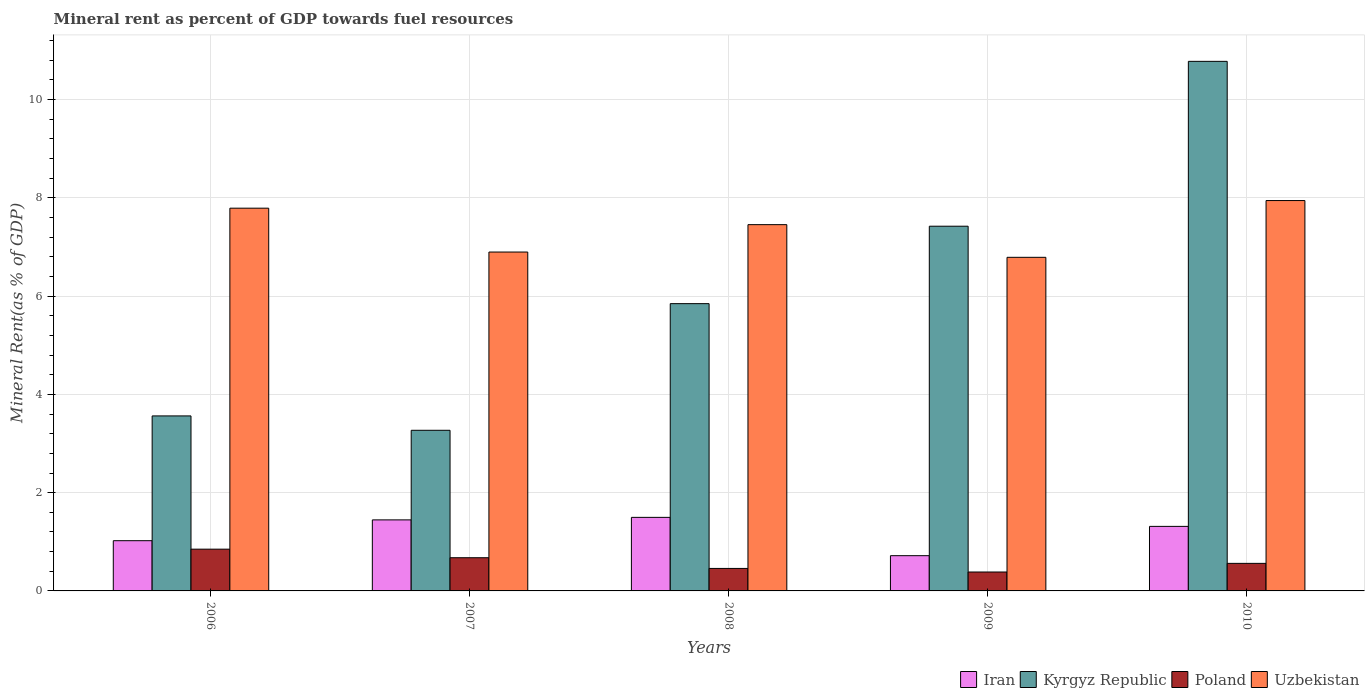How many different coloured bars are there?
Give a very brief answer. 4. How many groups of bars are there?
Offer a very short reply. 5. What is the mineral rent in Iran in 2010?
Your response must be concise. 1.31. Across all years, what is the maximum mineral rent in Uzbekistan?
Your answer should be compact. 7.95. Across all years, what is the minimum mineral rent in Poland?
Your answer should be very brief. 0.39. In which year was the mineral rent in Iran maximum?
Keep it short and to the point. 2008. What is the total mineral rent in Iran in the graph?
Your answer should be compact. 6. What is the difference between the mineral rent in Kyrgyz Republic in 2007 and that in 2008?
Offer a very short reply. -2.58. What is the difference between the mineral rent in Iran in 2007 and the mineral rent in Poland in 2008?
Your answer should be compact. 0.99. What is the average mineral rent in Uzbekistan per year?
Provide a short and direct response. 7.38. In the year 2007, what is the difference between the mineral rent in Kyrgyz Republic and mineral rent in Uzbekistan?
Provide a short and direct response. -3.63. What is the ratio of the mineral rent in Iran in 2006 to that in 2007?
Offer a very short reply. 0.71. Is the difference between the mineral rent in Kyrgyz Republic in 2008 and 2010 greater than the difference between the mineral rent in Uzbekistan in 2008 and 2010?
Provide a succinct answer. No. What is the difference between the highest and the second highest mineral rent in Uzbekistan?
Keep it short and to the point. 0.16. What is the difference between the highest and the lowest mineral rent in Uzbekistan?
Give a very brief answer. 1.16. In how many years, is the mineral rent in Kyrgyz Republic greater than the average mineral rent in Kyrgyz Republic taken over all years?
Your response must be concise. 2. Is it the case that in every year, the sum of the mineral rent in Poland and mineral rent in Iran is greater than the sum of mineral rent in Uzbekistan and mineral rent in Kyrgyz Republic?
Your answer should be very brief. No. What does the 1st bar from the left in 2008 represents?
Provide a short and direct response. Iran. What does the 1st bar from the right in 2007 represents?
Provide a succinct answer. Uzbekistan. Are all the bars in the graph horizontal?
Offer a very short reply. No. How many years are there in the graph?
Keep it short and to the point. 5. Are the values on the major ticks of Y-axis written in scientific E-notation?
Ensure brevity in your answer.  No. Does the graph contain any zero values?
Make the answer very short. No. Where does the legend appear in the graph?
Your answer should be very brief. Bottom right. How many legend labels are there?
Provide a succinct answer. 4. How are the legend labels stacked?
Your answer should be compact. Horizontal. What is the title of the graph?
Offer a very short reply. Mineral rent as percent of GDP towards fuel resources. Does "High income: nonOECD" appear as one of the legend labels in the graph?
Keep it short and to the point. No. What is the label or title of the X-axis?
Your answer should be very brief. Years. What is the label or title of the Y-axis?
Keep it short and to the point. Mineral Rent(as % of GDP). What is the Mineral Rent(as % of GDP) of Iran in 2006?
Make the answer very short. 1.02. What is the Mineral Rent(as % of GDP) of Kyrgyz Republic in 2006?
Provide a succinct answer. 3.56. What is the Mineral Rent(as % of GDP) in Poland in 2006?
Offer a terse response. 0.85. What is the Mineral Rent(as % of GDP) of Uzbekistan in 2006?
Keep it short and to the point. 7.79. What is the Mineral Rent(as % of GDP) in Iran in 2007?
Your answer should be compact. 1.45. What is the Mineral Rent(as % of GDP) in Kyrgyz Republic in 2007?
Provide a succinct answer. 3.27. What is the Mineral Rent(as % of GDP) in Poland in 2007?
Make the answer very short. 0.68. What is the Mineral Rent(as % of GDP) of Uzbekistan in 2007?
Provide a short and direct response. 6.9. What is the Mineral Rent(as % of GDP) of Iran in 2008?
Keep it short and to the point. 1.5. What is the Mineral Rent(as % of GDP) of Kyrgyz Republic in 2008?
Give a very brief answer. 5.85. What is the Mineral Rent(as % of GDP) in Poland in 2008?
Your response must be concise. 0.46. What is the Mineral Rent(as % of GDP) in Uzbekistan in 2008?
Your response must be concise. 7.45. What is the Mineral Rent(as % of GDP) of Iran in 2009?
Your answer should be very brief. 0.72. What is the Mineral Rent(as % of GDP) in Kyrgyz Republic in 2009?
Offer a terse response. 7.42. What is the Mineral Rent(as % of GDP) in Poland in 2009?
Provide a short and direct response. 0.39. What is the Mineral Rent(as % of GDP) of Uzbekistan in 2009?
Your answer should be compact. 6.79. What is the Mineral Rent(as % of GDP) of Iran in 2010?
Make the answer very short. 1.31. What is the Mineral Rent(as % of GDP) in Kyrgyz Republic in 2010?
Your response must be concise. 10.78. What is the Mineral Rent(as % of GDP) in Poland in 2010?
Your answer should be compact. 0.56. What is the Mineral Rent(as % of GDP) in Uzbekistan in 2010?
Keep it short and to the point. 7.95. Across all years, what is the maximum Mineral Rent(as % of GDP) in Iran?
Your response must be concise. 1.5. Across all years, what is the maximum Mineral Rent(as % of GDP) in Kyrgyz Republic?
Provide a succinct answer. 10.78. Across all years, what is the maximum Mineral Rent(as % of GDP) in Poland?
Offer a very short reply. 0.85. Across all years, what is the maximum Mineral Rent(as % of GDP) in Uzbekistan?
Make the answer very short. 7.95. Across all years, what is the minimum Mineral Rent(as % of GDP) in Iran?
Provide a short and direct response. 0.72. Across all years, what is the minimum Mineral Rent(as % of GDP) in Kyrgyz Republic?
Keep it short and to the point. 3.27. Across all years, what is the minimum Mineral Rent(as % of GDP) of Poland?
Your response must be concise. 0.39. Across all years, what is the minimum Mineral Rent(as % of GDP) of Uzbekistan?
Your answer should be very brief. 6.79. What is the total Mineral Rent(as % of GDP) in Iran in the graph?
Your answer should be very brief. 6. What is the total Mineral Rent(as % of GDP) of Kyrgyz Republic in the graph?
Give a very brief answer. 30.88. What is the total Mineral Rent(as % of GDP) of Poland in the graph?
Offer a very short reply. 2.93. What is the total Mineral Rent(as % of GDP) in Uzbekistan in the graph?
Provide a succinct answer. 36.88. What is the difference between the Mineral Rent(as % of GDP) in Iran in 2006 and that in 2007?
Provide a succinct answer. -0.42. What is the difference between the Mineral Rent(as % of GDP) of Kyrgyz Republic in 2006 and that in 2007?
Your answer should be compact. 0.29. What is the difference between the Mineral Rent(as % of GDP) of Poland in 2006 and that in 2007?
Your answer should be compact. 0.17. What is the difference between the Mineral Rent(as % of GDP) in Uzbekistan in 2006 and that in 2007?
Offer a very short reply. 0.89. What is the difference between the Mineral Rent(as % of GDP) in Iran in 2006 and that in 2008?
Ensure brevity in your answer.  -0.47. What is the difference between the Mineral Rent(as % of GDP) in Kyrgyz Republic in 2006 and that in 2008?
Keep it short and to the point. -2.29. What is the difference between the Mineral Rent(as % of GDP) of Poland in 2006 and that in 2008?
Your answer should be compact. 0.39. What is the difference between the Mineral Rent(as % of GDP) in Uzbekistan in 2006 and that in 2008?
Ensure brevity in your answer.  0.34. What is the difference between the Mineral Rent(as % of GDP) in Iran in 2006 and that in 2009?
Your answer should be very brief. 0.31. What is the difference between the Mineral Rent(as % of GDP) of Kyrgyz Republic in 2006 and that in 2009?
Offer a very short reply. -3.86. What is the difference between the Mineral Rent(as % of GDP) in Poland in 2006 and that in 2009?
Offer a terse response. 0.46. What is the difference between the Mineral Rent(as % of GDP) of Iran in 2006 and that in 2010?
Offer a terse response. -0.29. What is the difference between the Mineral Rent(as % of GDP) in Kyrgyz Republic in 2006 and that in 2010?
Ensure brevity in your answer.  -7.22. What is the difference between the Mineral Rent(as % of GDP) of Poland in 2006 and that in 2010?
Your answer should be compact. 0.29. What is the difference between the Mineral Rent(as % of GDP) in Uzbekistan in 2006 and that in 2010?
Ensure brevity in your answer.  -0.16. What is the difference between the Mineral Rent(as % of GDP) of Iran in 2007 and that in 2008?
Provide a succinct answer. -0.05. What is the difference between the Mineral Rent(as % of GDP) in Kyrgyz Republic in 2007 and that in 2008?
Your answer should be very brief. -2.58. What is the difference between the Mineral Rent(as % of GDP) of Poland in 2007 and that in 2008?
Your answer should be compact. 0.22. What is the difference between the Mineral Rent(as % of GDP) of Uzbekistan in 2007 and that in 2008?
Provide a short and direct response. -0.56. What is the difference between the Mineral Rent(as % of GDP) of Iran in 2007 and that in 2009?
Ensure brevity in your answer.  0.73. What is the difference between the Mineral Rent(as % of GDP) in Kyrgyz Republic in 2007 and that in 2009?
Your answer should be very brief. -4.15. What is the difference between the Mineral Rent(as % of GDP) in Poland in 2007 and that in 2009?
Offer a very short reply. 0.29. What is the difference between the Mineral Rent(as % of GDP) of Uzbekistan in 2007 and that in 2009?
Make the answer very short. 0.11. What is the difference between the Mineral Rent(as % of GDP) in Iran in 2007 and that in 2010?
Make the answer very short. 0.13. What is the difference between the Mineral Rent(as % of GDP) in Kyrgyz Republic in 2007 and that in 2010?
Your answer should be very brief. -7.51. What is the difference between the Mineral Rent(as % of GDP) in Poland in 2007 and that in 2010?
Your answer should be compact. 0.11. What is the difference between the Mineral Rent(as % of GDP) of Uzbekistan in 2007 and that in 2010?
Ensure brevity in your answer.  -1.05. What is the difference between the Mineral Rent(as % of GDP) of Iran in 2008 and that in 2009?
Provide a short and direct response. 0.78. What is the difference between the Mineral Rent(as % of GDP) in Kyrgyz Republic in 2008 and that in 2009?
Your response must be concise. -1.58. What is the difference between the Mineral Rent(as % of GDP) in Poland in 2008 and that in 2009?
Your response must be concise. 0.07. What is the difference between the Mineral Rent(as % of GDP) in Uzbekistan in 2008 and that in 2009?
Make the answer very short. 0.66. What is the difference between the Mineral Rent(as % of GDP) in Iran in 2008 and that in 2010?
Make the answer very short. 0.18. What is the difference between the Mineral Rent(as % of GDP) of Kyrgyz Republic in 2008 and that in 2010?
Ensure brevity in your answer.  -4.93. What is the difference between the Mineral Rent(as % of GDP) of Poland in 2008 and that in 2010?
Provide a short and direct response. -0.1. What is the difference between the Mineral Rent(as % of GDP) of Uzbekistan in 2008 and that in 2010?
Offer a very short reply. -0.49. What is the difference between the Mineral Rent(as % of GDP) in Iran in 2009 and that in 2010?
Provide a short and direct response. -0.6. What is the difference between the Mineral Rent(as % of GDP) in Kyrgyz Republic in 2009 and that in 2010?
Make the answer very short. -3.36. What is the difference between the Mineral Rent(as % of GDP) of Poland in 2009 and that in 2010?
Provide a succinct answer. -0.18. What is the difference between the Mineral Rent(as % of GDP) of Uzbekistan in 2009 and that in 2010?
Offer a terse response. -1.16. What is the difference between the Mineral Rent(as % of GDP) in Iran in 2006 and the Mineral Rent(as % of GDP) in Kyrgyz Republic in 2007?
Give a very brief answer. -2.25. What is the difference between the Mineral Rent(as % of GDP) in Iran in 2006 and the Mineral Rent(as % of GDP) in Poland in 2007?
Your response must be concise. 0.35. What is the difference between the Mineral Rent(as % of GDP) in Iran in 2006 and the Mineral Rent(as % of GDP) in Uzbekistan in 2007?
Your answer should be compact. -5.88. What is the difference between the Mineral Rent(as % of GDP) of Kyrgyz Republic in 2006 and the Mineral Rent(as % of GDP) of Poland in 2007?
Keep it short and to the point. 2.89. What is the difference between the Mineral Rent(as % of GDP) of Kyrgyz Republic in 2006 and the Mineral Rent(as % of GDP) of Uzbekistan in 2007?
Your answer should be compact. -3.34. What is the difference between the Mineral Rent(as % of GDP) of Poland in 2006 and the Mineral Rent(as % of GDP) of Uzbekistan in 2007?
Ensure brevity in your answer.  -6.05. What is the difference between the Mineral Rent(as % of GDP) of Iran in 2006 and the Mineral Rent(as % of GDP) of Kyrgyz Republic in 2008?
Provide a short and direct response. -4.82. What is the difference between the Mineral Rent(as % of GDP) in Iran in 2006 and the Mineral Rent(as % of GDP) in Poland in 2008?
Keep it short and to the point. 0.56. What is the difference between the Mineral Rent(as % of GDP) of Iran in 2006 and the Mineral Rent(as % of GDP) of Uzbekistan in 2008?
Your answer should be very brief. -6.43. What is the difference between the Mineral Rent(as % of GDP) of Kyrgyz Republic in 2006 and the Mineral Rent(as % of GDP) of Poland in 2008?
Your response must be concise. 3.1. What is the difference between the Mineral Rent(as % of GDP) of Kyrgyz Republic in 2006 and the Mineral Rent(as % of GDP) of Uzbekistan in 2008?
Your answer should be very brief. -3.89. What is the difference between the Mineral Rent(as % of GDP) of Poland in 2006 and the Mineral Rent(as % of GDP) of Uzbekistan in 2008?
Give a very brief answer. -6.6. What is the difference between the Mineral Rent(as % of GDP) of Iran in 2006 and the Mineral Rent(as % of GDP) of Kyrgyz Republic in 2009?
Your answer should be very brief. -6.4. What is the difference between the Mineral Rent(as % of GDP) in Iran in 2006 and the Mineral Rent(as % of GDP) in Poland in 2009?
Provide a succinct answer. 0.64. What is the difference between the Mineral Rent(as % of GDP) of Iran in 2006 and the Mineral Rent(as % of GDP) of Uzbekistan in 2009?
Provide a succinct answer. -5.77. What is the difference between the Mineral Rent(as % of GDP) of Kyrgyz Republic in 2006 and the Mineral Rent(as % of GDP) of Poland in 2009?
Ensure brevity in your answer.  3.18. What is the difference between the Mineral Rent(as % of GDP) in Kyrgyz Republic in 2006 and the Mineral Rent(as % of GDP) in Uzbekistan in 2009?
Your response must be concise. -3.23. What is the difference between the Mineral Rent(as % of GDP) in Poland in 2006 and the Mineral Rent(as % of GDP) in Uzbekistan in 2009?
Offer a terse response. -5.94. What is the difference between the Mineral Rent(as % of GDP) in Iran in 2006 and the Mineral Rent(as % of GDP) in Kyrgyz Republic in 2010?
Your answer should be compact. -9.76. What is the difference between the Mineral Rent(as % of GDP) in Iran in 2006 and the Mineral Rent(as % of GDP) in Poland in 2010?
Make the answer very short. 0.46. What is the difference between the Mineral Rent(as % of GDP) of Iran in 2006 and the Mineral Rent(as % of GDP) of Uzbekistan in 2010?
Your answer should be very brief. -6.92. What is the difference between the Mineral Rent(as % of GDP) in Kyrgyz Republic in 2006 and the Mineral Rent(as % of GDP) in Poland in 2010?
Your answer should be compact. 3. What is the difference between the Mineral Rent(as % of GDP) of Kyrgyz Republic in 2006 and the Mineral Rent(as % of GDP) of Uzbekistan in 2010?
Make the answer very short. -4.38. What is the difference between the Mineral Rent(as % of GDP) in Poland in 2006 and the Mineral Rent(as % of GDP) in Uzbekistan in 2010?
Your answer should be very brief. -7.1. What is the difference between the Mineral Rent(as % of GDP) of Iran in 2007 and the Mineral Rent(as % of GDP) of Kyrgyz Republic in 2008?
Offer a very short reply. -4.4. What is the difference between the Mineral Rent(as % of GDP) in Iran in 2007 and the Mineral Rent(as % of GDP) in Poland in 2008?
Keep it short and to the point. 0.99. What is the difference between the Mineral Rent(as % of GDP) of Iran in 2007 and the Mineral Rent(as % of GDP) of Uzbekistan in 2008?
Make the answer very short. -6.01. What is the difference between the Mineral Rent(as % of GDP) in Kyrgyz Republic in 2007 and the Mineral Rent(as % of GDP) in Poland in 2008?
Give a very brief answer. 2.81. What is the difference between the Mineral Rent(as % of GDP) in Kyrgyz Republic in 2007 and the Mineral Rent(as % of GDP) in Uzbekistan in 2008?
Your answer should be very brief. -4.19. What is the difference between the Mineral Rent(as % of GDP) of Poland in 2007 and the Mineral Rent(as % of GDP) of Uzbekistan in 2008?
Provide a succinct answer. -6.78. What is the difference between the Mineral Rent(as % of GDP) of Iran in 2007 and the Mineral Rent(as % of GDP) of Kyrgyz Republic in 2009?
Your answer should be compact. -5.98. What is the difference between the Mineral Rent(as % of GDP) in Iran in 2007 and the Mineral Rent(as % of GDP) in Poland in 2009?
Your response must be concise. 1.06. What is the difference between the Mineral Rent(as % of GDP) in Iran in 2007 and the Mineral Rent(as % of GDP) in Uzbekistan in 2009?
Offer a very short reply. -5.34. What is the difference between the Mineral Rent(as % of GDP) in Kyrgyz Republic in 2007 and the Mineral Rent(as % of GDP) in Poland in 2009?
Ensure brevity in your answer.  2.88. What is the difference between the Mineral Rent(as % of GDP) of Kyrgyz Republic in 2007 and the Mineral Rent(as % of GDP) of Uzbekistan in 2009?
Make the answer very short. -3.52. What is the difference between the Mineral Rent(as % of GDP) of Poland in 2007 and the Mineral Rent(as % of GDP) of Uzbekistan in 2009?
Your answer should be very brief. -6.11. What is the difference between the Mineral Rent(as % of GDP) in Iran in 2007 and the Mineral Rent(as % of GDP) in Kyrgyz Republic in 2010?
Your answer should be very brief. -9.33. What is the difference between the Mineral Rent(as % of GDP) of Iran in 2007 and the Mineral Rent(as % of GDP) of Poland in 2010?
Provide a succinct answer. 0.89. What is the difference between the Mineral Rent(as % of GDP) of Iran in 2007 and the Mineral Rent(as % of GDP) of Uzbekistan in 2010?
Make the answer very short. -6.5. What is the difference between the Mineral Rent(as % of GDP) in Kyrgyz Republic in 2007 and the Mineral Rent(as % of GDP) in Poland in 2010?
Your answer should be compact. 2.71. What is the difference between the Mineral Rent(as % of GDP) of Kyrgyz Republic in 2007 and the Mineral Rent(as % of GDP) of Uzbekistan in 2010?
Give a very brief answer. -4.68. What is the difference between the Mineral Rent(as % of GDP) in Poland in 2007 and the Mineral Rent(as % of GDP) in Uzbekistan in 2010?
Your answer should be compact. -7.27. What is the difference between the Mineral Rent(as % of GDP) in Iran in 2008 and the Mineral Rent(as % of GDP) in Kyrgyz Republic in 2009?
Make the answer very short. -5.93. What is the difference between the Mineral Rent(as % of GDP) in Iran in 2008 and the Mineral Rent(as % of GDP) in Poland in 2009?
Ensure brevity in your answer.  1.11. What is the difference between the Mineral Rent(as % of GDP) of Iran in 2008 and the Mineral Rent(as % of GDP) of Uzbekistan in 2009?
Provide a succinct answer. -5.29. What is the difference between the Mineral Rent(as % of GDP) in Kyrgyz Republic in 2008 and the Mineral Rent(as % of GDP) in Poland in 2009?
Offer a very short reply. 5.46. What is the difference between the Mineral Rent(as % of GDP) of Kyrgyz Republic in 2008 and the Mineral Rent(as % of GDP) of Uzbekistan in 2009?
Make the answer very short. -0.94. What is the difference between the Mineral Rent(as % of GDP) of Poland in 2008 and the Mineral Rent(as % of GDP) of Uzbekistan in 2009?
Make the answer very short. -6.33. What is the difference between the Mineral Rent(as % of GDP) of Iran in 2008 and the Mineral Rent(as % of GDP) of Kyrgyz Republic in 2010?
Make the answer very short. -9.28. What is the difference between the Mineral Rent(as % of GDP) of Iran in 2008 and the Mineral Rent(as % of GDP) of Poland in 2010?
Offer a terse response. 0.94. What is the difference between the Mineral Rent(as % of GDP) in Iran in 2008 and the Mineral Rent(as % of GDP) in Uzbekistan in 2010?
Your response must be concise. -6.45. What is the difference between the Mineral Rent(as % of GDP) of Kyrgyz Republic in 2008 and the Mineral Rent(as % of GDP) of Poland in 2010?
Your answer should be very brief. 5.29. What is the difference between the Mineral Rent(as % of GDP) in Kyrgyz Republic in 2008 and the Mineral Rent(as % of GDP) in Uzbekistan in 2010?
Provide a short and direct response. -2.1. What is the difference between the Mineral Rent(as % of GDP) in Poland in 2008 and the Mineral Rent(as % of GDP) in Uzbekistan in 2010?
Your response must be concise. -7.49. What is the difference between the Mineral Rent(as % of GDP) in Iran in 2009 and the Mineral Rent(as % of GDP) in Kyrgyz Republic in 2010?
Make the answer very short. -10.06. What is the difference between the Mineral Rent(as % of GDP) of Iran in 2009 and the Mineral Rent(as % of GDP) of Poland in 2010?
Ensure brevity in your answer.  0.16. What is the difference between the Mineral Rent(as % of GDP) of Iran in 2009 and the Mineral Rent(as % of GDP) of Uzbekistan in 2010?
Give a very brief answer. -7.23. What is the difference between the Mineral Rent(as % of GDP) in Kyrgyz Republic in 2009 and the Mineral Rent(as % of GDP) in Poland in 2010?
Offer a terse response. 6.86. What is the difference between the Mineral Rent(as % of GDP) in Kyrgyz Republic in 2009 and the Mineral Rent(as % of GDP) in Uzbekistan in 2010?
Offer a terse response. -0.52. What is the difference between the Mineral Rent(as % of GDP) in Poland in 2009 and the Mineral Rent(as % of GDP) in Uzbekistan in 2010?
Your answer should be compact. -7.56. What is the average Mineral Rent(as % of GDP) in Iran per year?
Your answer should be compact. 1.2. What is the average Mineral Rent(as % of GDP) in Kyrgyz Republic per year?
Give a very brief answer. 6.18. What is the average Mineral Rent(as % of GDP) of Poland per year?
Provide a short and direct response. 0.59. What is the average Mineral Rent(as % of GDP) of Uzbekistan per year?
Provide a short and direct response. 7.38. In the year 2006, what is the difference between the Mineral Rent(as % of GDP) of Iran and Mineral Rent(as % of GDP) of Kyrgyz Republic?
Your response must be concise. -2.54. In the year 2006, what is the difference between the Mineral Rent(as % of GDP) of Iran and Mineral Rent(as % of GDP) of Poland?
Your answer should be very brief. 0.17. In the year 2006, what is the difference between the Mineral Rent(as % of GDP) in Iran and Mineral Rent(as % of GDP) in Uzbekistan?
Provide a short and direct response. -6.77. In the year 2006, what is the difference between the Mineral Rent(as % of GDP) in Kyrgyz Republic and Mineral Rent(as % of GDP) in Poland?
Your answer should be very brief. 2.71. In the year 2006, what is the difference between the Mineral Rent(as % of GDP) in Kyrgyz Republic and Mineral Rent(as % of GDP) in Uzbekistan?
Your answer should be very brief. -4.23. In the year 2006, what is the difference between the Mineral Rent(as % of GDP) in Poland and Mineral Rent(as % of GDP) in Uzbekistan?
Offer a very short reply. -6.94. In the year 2007, what is the difference between the Mineral Rent(as % of GDP) of Iran and Mineral Rent(as % of GDP) of Kyrgyz Republic?
Provide a short and direct response. -1.82. In the year 2007, what is the difference between the Mineral Rent(as % of GDP) of Iran and Mineral Rent(as % of GDP) of Poland?
Make the answer very short. 0.77. In the year 2007, what is the difference between the Mineral Rent(as % of GDP) of Iran and Mineral Rent(as % of GDP) of Uzbekistan?
Make the answer very short. -5.45. In the year 2007, what is the difference between the Mineral Rent(as % of GDP) in Kyrgyz Republic and Mineral Rent(as % of GDP) in Poland?
Make the answer very short. 2.59. In the year 2007, what is the difference between the Mineral Rent(as % of GDP) of Kyrgyz Republic and Mineral Rent(as % of GDP) of Uzbekistan?
Your answer should be very brief. -3.63. In the year 2007, what is the difference between the Mineral Rent(as % of GDP) in Poland and Mineral Rent(as % of GDP) in Uzbekistan?
Make the answer very short. -6.22. In the year 2008, what is the difference between the Mineral Rent(as % of GDP) of Iran and Mineral Rent(as % of GDP) of Kyrgyz Republic?
Provide a succinct answer. -4.35. In the year 2008, what is the difference between the Mineral Rent(as % of GDP) in Iran and Mineral Rent(as % of GDP) in Poland?
Your answer should be very brief. 1.04. In the year 2008, what is the difference between the Mineral Rent(as % of GDP) of Iran and Mineral Rent(as % of GDP) of Uzbekistan?
Make the answer very short. -5.96. In the year 2008, what is the difference between the Mineral Rent(as % of GDP) of Kyrgyz Republic and Mineral Rent(as % of GDP) of Poland?
Offer a very short reply. 5.39. In the year 2008, what is the difference between the Mineral Rent(as % of GDP) in Kyrgyz Republic and Mineral Rent(as % of GDP) in Uzbekistan?
Your answer should be very brief. -1.61. In the year 2008, what is the difference between the Mineral Rent(as % of GDP) in Poland and Mineral Rent(as % of GDP) in Uzbekistan?
Your response must be concise. -7. In the year 2009, what is the difference between the Mineral Rent(as % of GDP) of Iran and Mineral Rent(as % of GDP) of Kyrgyz Republic?
Offer a terse response. -6.71. In the year 2009, what is the difference between the Mineral Rent(as % of GDP) of Iran and Mineral Rent(as % of GDP) of Poland?
Offer a terse response. 0.33. In the year 2009, what is the difference between the Mineral Rent(as % of GDP) of Iran and Mineral Rent(as % of GDP) of Uzbekistan?
Offer a terse response. -6.07. In the year 2009, what is the difference between the Mineral Rent(as % of GDP) in Kyrgyz Republic and Mineral Rent(as % of GDP) in Poland?
Provide a short and direct response. 7.04. In the year 2009, what is the difference between the Mineral Rent(as % of GDP) in Kyrgyz Republic and Mineral Rent(as % of GDP) in Uzbekistan?
Offer a very short reply. 0.63. In the year 2009, what is the difference between the Mineral Rent(as % of GDP) of Poland and Mineral Rent(as % of GDP) of Uzbekistan?
Your response must be concise. -6.41. In the year 2010, what is the difference between the Mineral Rent(as % of GDP) in Iran and Mineral Rent(as % of GDP) in Kyrgyz Republic?
Provide a succinct answer. -9.47. In the year 2010, what is the difference between the Mineral Rent(as % of GDP) in Iran and Mineral Rent(as % of GDP) in Poland?
Provide a short and direct response. 0.75. In the year 2010, what is the difference between the Mineral Rent(as % of GDP) of Iran and Mineral Rent(as % of GDP) of Uzbekistan?
Offer a terse response. -6.63. In the year 2010, what is the difference between the Mineral Rent(as % of GDP) of Kyrgyz Republic and Mineral Rent(as % of GDP) of Poland?
Your response must be concise. 10.22. In the year 2010, what is the difference between the Mineral Rent(as % of GDP) of Kyrgyz Republic and Mineral Rent(as % of GDP) of Uzbekistan?
Give a very brief answer. 2.83. In the year 2010, what is the difference between the Mineral Rent(as % of GDP) of Poland and Mineral Rent(as % of GDP) of Uzbekistan?
Offer a terse response. -7.38. What is the ratio of the Mineral Rent(as % of GDP) in Iran in 2006 to that in 2007?
Keep it short and to the point. 0.71. What is the ratio of the Mineral Rent(as % of GDP) of Kyrgyz Republic in 2006 to that in 2007?
Offer a very short reply. 1.09. What is the ratio of the Mineral Rent(as % of GDP) of Poland in 2006 to that in 2007?
Provide a succinct answer. 1.26. What is the ratio of the Mineral Rent(as % of GDP) of Uzbekistan in 2006 to that in 2007?
Keep it short and to the point. 1.13. What is the ratio of the Mineral Rent(as % of GDP) of Iran in 2006 to that in 2008?
Provide a succinct answer. 0.68. What is the ratio of the Mineral Rent(as % of GDP) in Kyrgyz Republic in 2006 to that in 2008?
Your answer should be very brief. 0.61. What is the ratio of the Mineral Rent(as % of GDP) of Poland in 2006 to that in 2008?
Your answer should be compact. 1.86. What is the ratio of the Mineral Rent(as % of GDP) of Uzbekistan in 2006 to that in 2008?
Provide a succinct answer. 1.04. What is the ratio of the Mineral Rent(as % of GDP) in Iran in 2006 to that in 2009?
Your answer should be very brief. 1.43. What is the ratio of the Mineral Rent(as % of GDP) of Kyrgyz Republic in 2006 to that in 2009?
Provide a succinct answer. 0.48. What is the ratio of the Mineral Rent(as % of GDP) of Poland in 2006 to that in 2009?
Give a very brief answer. 2.21. What is the ratio of the Mineral Rent(as % of GDP) of Uzbekistan in 2006 to that in 2009?
Provide a succinct answer. 1.15. What is the ratio of the Mineral Rent(as % of GDP) of Iran in 2006 to that in 2010?
Offer a terse response. 0.78. What is the ratio of the Mineral Rent(as % of GDP) in Kyrgyz Republic in 2006 to that in 2010?
Your response must be concise. 0.33. What is the ratio of the Mineral Rent(as % of GDP) in Poland in 2006 to that in 2010?
Your response must be concise. 1.52. What is the ratio of the Mineral Rent(as % of GDP) of Uzbekistan in 2006 to that in 2010?
Offer a very short reply. 0.98. What is the ratio of the Mineral Rent(as % of GDP) of Iran in 2007 to that in 2008?
Provide a short and direct response. 0.97. What is the ratio of the Mineral Rent(as % of GDP) in Kyrgyz Republic in 2007 to that in 2008?
Ensure brevity in your answer.  0.56. What is the ratio of the Mineral Rent(as % of GDP) in Poland in 2007 to that in 2008?
Your response must be concise. 1.48. What is the ratio of the Mineral Rent(as % of GDP) in Uzbekistan in 2007 to that in 2008?
Provide a succinct answer. 0.93. What is the ratio of the Mineral Rent(as % of GDP) in Iran in 2007 to that in 2009?
Ensure brevity in your answer.  2.02. What is the ratio of the Mineral Rent(as % of GDP) of Kyrgyz Republic in 2007 to that in 2009?
Offer a terse response. 0.44. What is the ratio of the Mineral Rent(as % of GDP) in Poland in 2007 to that in 2009?
Provide a short and direct response. 1.75. What is the ratio of the Mineral Rent(as % of GDP) of Uzbekistan in 2007 to that in 2009?
Ensure brevity in your answer.  1.02. What is the ratio of the Mineral Rent(as % of GDP) in Iran in 2007 to that in 2010?
Your answer should be very brief. 1.1. What is the ratio of the Mineral Rent(as % of GDP) of Kyrgyz Republic in 2007 to that in 2010?
Provide a short and direct response. 0.3. What is the ratio of the Mineral Rent(as % of GDP) of Poland in 2007 to that in 2010?
Your answer should be compact. 1.2. What is the ratio of the Mineral Rent(as % of GDP) of Uzbekistan in 2007 to that in 2010?
Your answer should be very brief. 0.87. What is the ratio of the Mineral Rent(as % of GDP) of Iran in 2008 to that in 2009?
Offer a very short reply. 2.09. What is the ratio of the Mineral Rent(as % of GDP) in Kyrgyz Republic in 2008 to that in 2009?
Provide a succinct answer. 0.79. What is the ratio of the Mineral Rent(as % of GDP) of Poland in 2008 to that in 2009?
Provide a succinct answer. 1.19. What is the ratio of the Mineral Rent(as % of GDP) of Uzbekistan in 2008 to that in 2009?
Give a very brief answer. 1.1. What is the ratio of the Mineral Rent(as % of GDP) of Iran in 2008 to that in 2010?
Your answer should be compact. 1.14. What is the ratio of the Mineral Rent(as % of GDP) in Kyrgyz Republic in 2008 to that in 2010?
Ensure brevity in your answer.  0.54. What is the ratio of the Mineral Rent(as % of GDP) of Poland in 2008 to that in 2010?
Ensure brevity in your answer.  0.82. What is the ratio of the Mineral Rent(as % of GDP) of Uzbekistan in 2008 to that in 2010?
Keep it short and to the point. 0.94. What is the ratio of the Mineral Rent(as % of GDP) in Iran in 2009 to that in 2010?
Ensure brevity in your answer.  0.55. What is the ratio of the Mineral Rent(as % of GDP) of Kyrgyz Republic in 2009 to that in 2010?
Offer a terse response. 0.69. What is the ratio of the Mineral Rent(as % of GDP) of Poland in 2009 to that in 2010?
Provide a short and direct response. 0.69. What is the ratio of the Mineral Rent(as % of GDP) in Uzbekistan in 2009 to that in 2010?
Provide a succinct answer. 0.85. What is the difference between the highest and the second highest Mineral Rent(as % of GDP) in Iran?
Make the answer very short. 0.05. What is the difference between the highest and the second highest Mineral Rent(as % of GDP) in Kyrgyz Republic?
Offer a very short reply. 3.36. What is the difference between the highest and the second highest Mineral Rent(as % of GDP) in Poland?
Your answer should be compact. 0.17. What is the difference between the highest and the second highest Mineral Rent(as % of GDP) of Uzbekistan?
Offer a terse response. 0.16. What is the difference between the highest and the lowest Mineral Rent(as % of GDP) in Iran?
Provide a short and direct response. 0.78. What is the difference between the highest and the lowest Mineral Rent(as % of GDP) of Kyrgyz Republic?
Offer a very short reply. 7.51. What is the difference between the highest and the lowest Mineral Rent(as % of GDP) of Poland?
Provide a short and direct response. 0.46. What is the difference between the highest and the lowest Mineral Rent(as % of GDP) in Uzbekistan?
Keep it short and to the point. 1.16. 